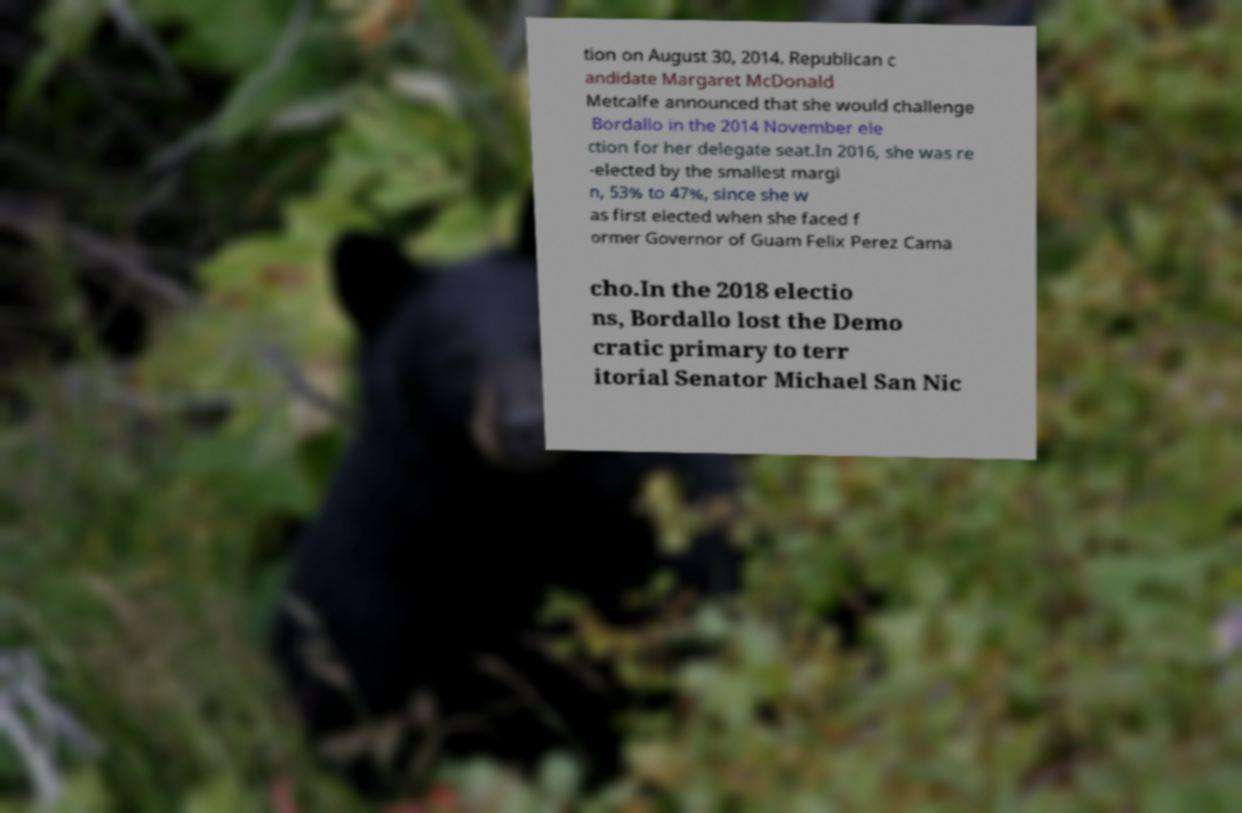Could you assist in decoding the text presented in this image and type it out clearly? tion on August 30, 2014. Republican c andidate Margaret McDonald Metcalfe announced that she would challenge Bordallo in the 2014 November ele ction for her delegate seat.In 2016, she was re -elected by the smallest margi n, 53% to 47%, since she w as first elected when she faced f ormer Governor of Guam Felix Perez Cama cho.In the 2018 electio ns, Bordallo lost the Demo cratic primary to terr itorial Senator Michael San Nic 